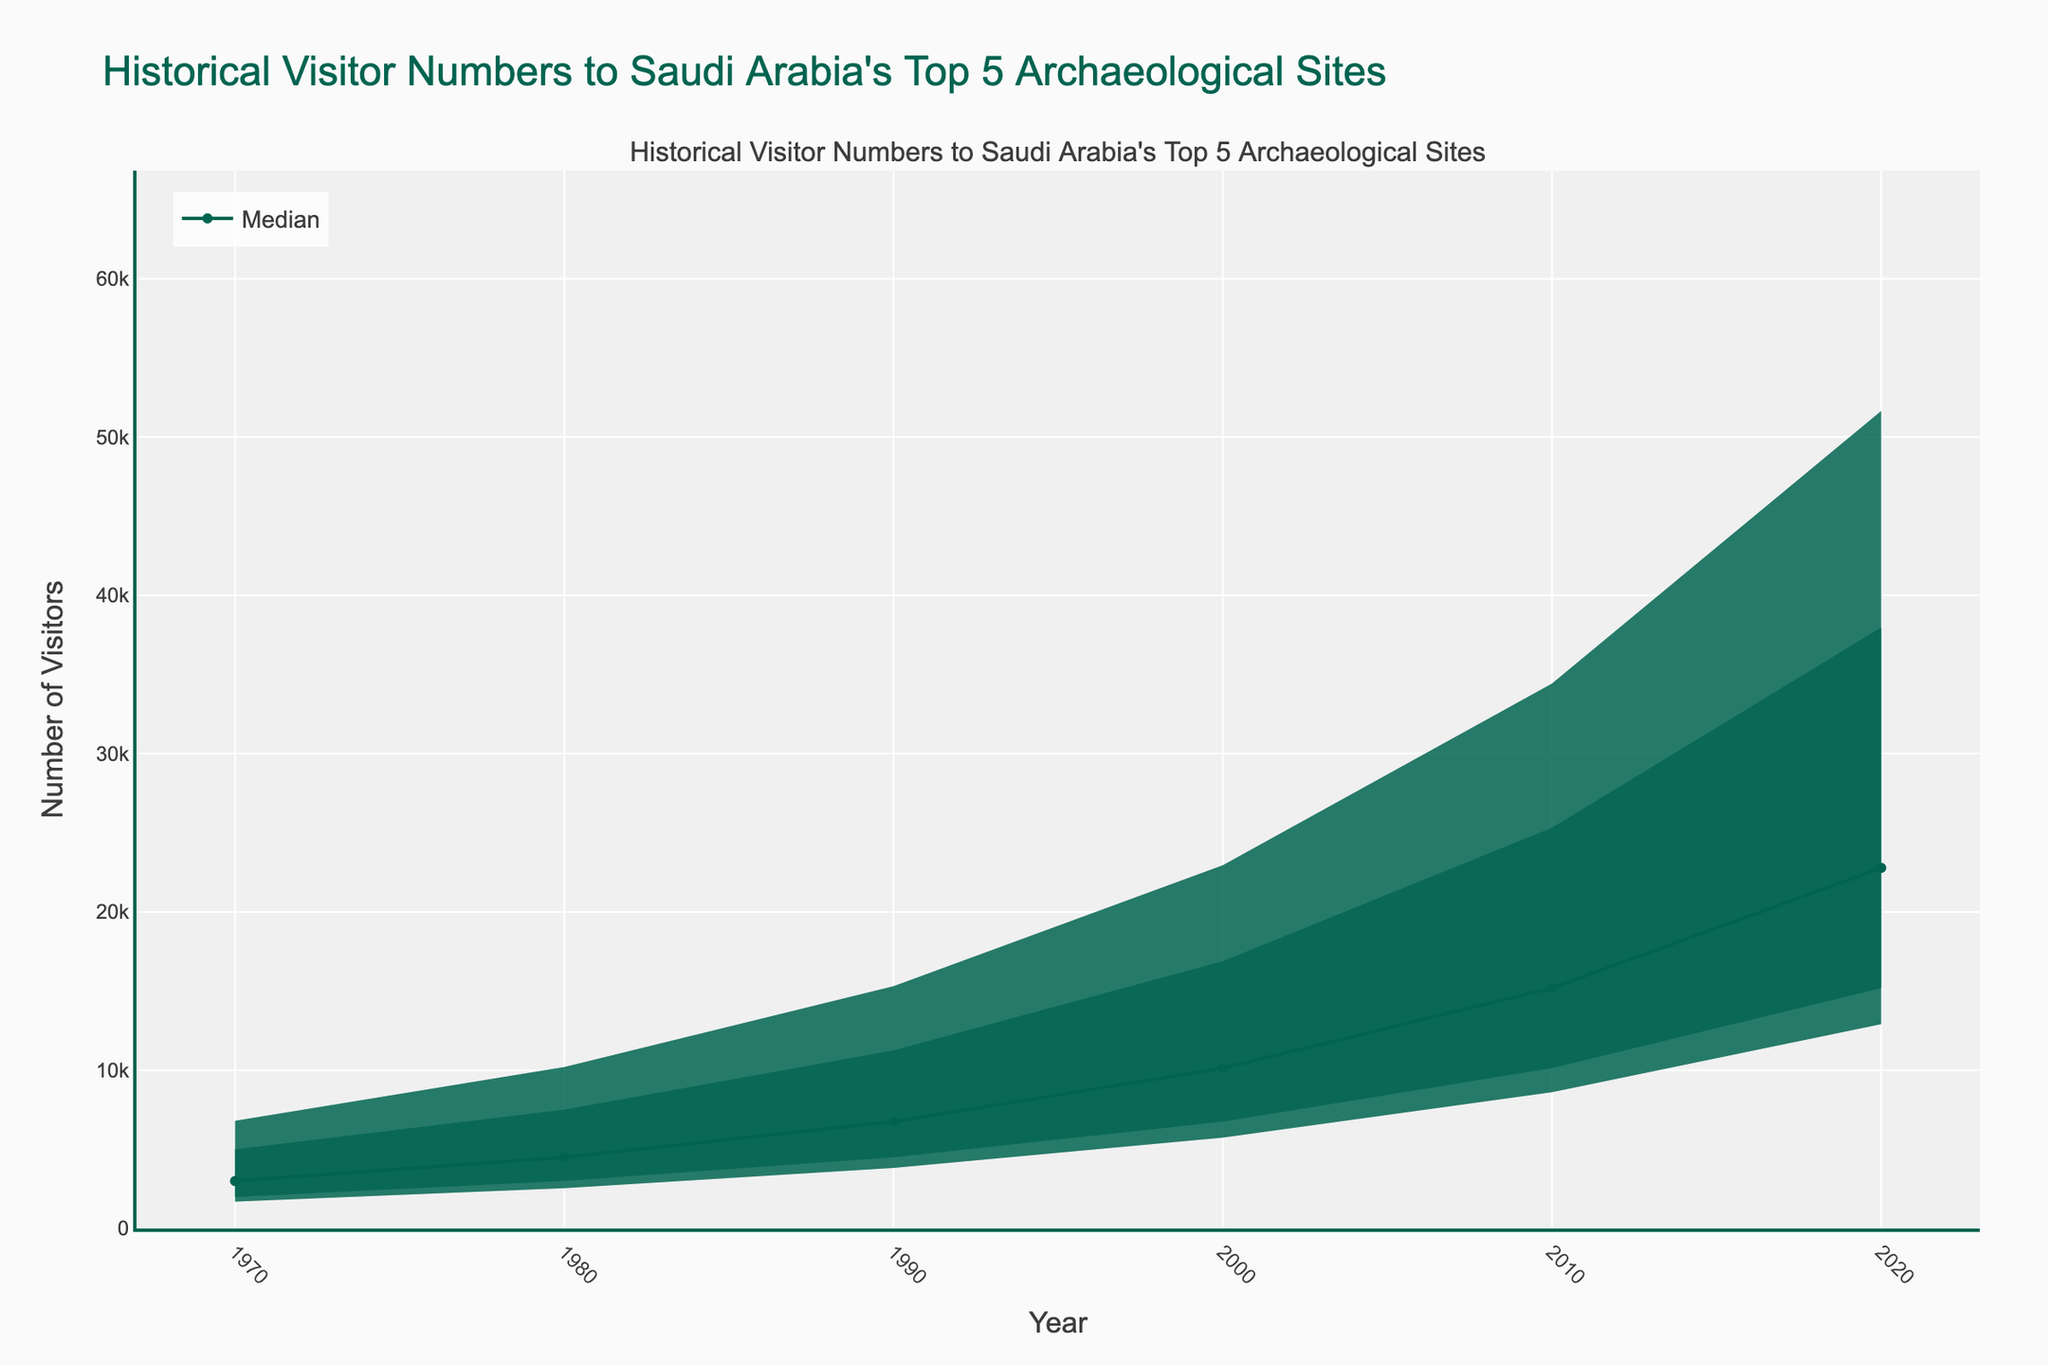What's the title of the figure? The title is located at the top of the chart. It provides an overview of what the figure represents.
Answer: Historical Visitor Numbers to Saudi Arabia's Top 5 Archaeological Sites What does the x-axis represent? The x-axis, located at the bottom of the chart, displays the timeline over which data has been recorded.
Answer: Year What is the range of the y-axis? The y-axis, found on the left side of the chart, indicates the number of visitors. The range is from 0 to slightly above the maximum data value to accommodate the highest visitor number with some margin.
Answer: 0 to around 42,000 What color represents the 75th percentile? In the fan chart, different percentiles are represented by different shades. The 75th percentile is identified by its specific fill color.
Answer: rgba(0,100,80,0.6) What is the median number of visitors to these archaeological sites in 2020? The median is shown by a line plot on the chart, and for the year 2020, it can be read directly from this line.
Answer: Around 22,781 Which site had the highest number of visitors in 2010? By examining the plotted data points for the year 2010, the site with the highest visitor number can be identified.
Answer: Diriyah How did the number of visitors to Madain Saleh change from 1970 to 2020? To determine this, compare the data points for Madain Saleh in 1970 and 2020. The difference will show the change in visitor numbers.
Answer: Increased from 5,000 to 37,968 Which percentile band is widest in 2020? The width of a percentile band at a particular year indicates the spread of the visitor numbers. By comparing the width of all bands at 2020, the widest one can be identified.
Answer: 10th-90th percentile What has been the trend for visitor numbers to these sites over the past 50 years? Observing the median line over the years will show whether the overall number of visitors has been increasing, decreasing, or remaining constant.
Answer: Increasing trend How do the visitor trends to Al-Ula compare to those of Jubbah between 2000 and 2020? By comparing the plotted data points for Al-Ula and Jubbah between the years 2000 and 2020, one can observe which site had a steeper increase or decrease in visitor numbers.
Answer: Al-Ula had a steeper increase in visitors compared to Jubbah 